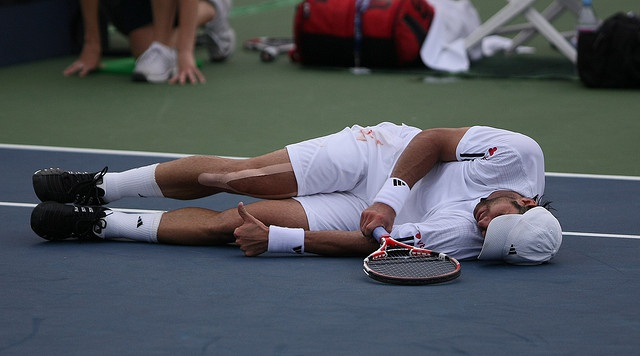Describe the objects in this image and their specific colors. I can see people in black, darkgray, and gray tones, people in black, maroon, gray, and brown tones, tennis racket in black, gray, and darkgray tones, and chair in black, gray, and darkgray tones in this image. 